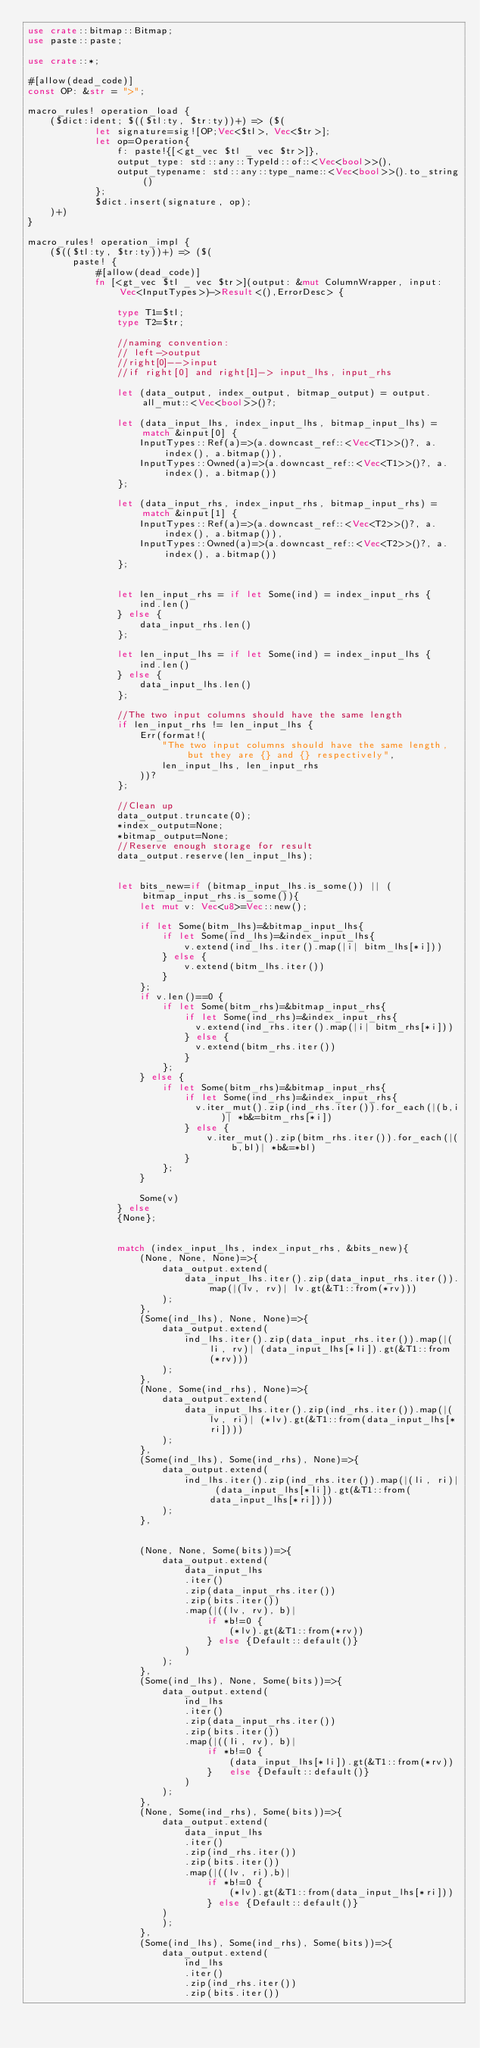<code> <loc_0><loc_0><loc_500><loc_500><_Rust_>use crate::bitmap::Bitmap;
use paste::paste;

use crate::*;

#[allow(dead_code)]
const OP: &str = ">";

macro_rules! operation_load {
    ($dict:ident; $(($tl:ty, $tr:ty))+) => ($(
            let signature=sig![OP;Vec<$tl>, Vec<$tr>];
            let op=Operation{
                f: paste!{[<gt_vec $tl _ vec $tr>]},
                output_type: std::any::TypeId::of::<Vec<bool>>(),
                output_typename: std::any::type_name::<Vec<bool>>().to_string()
            };
            $dict.insert(signature, op);
    )+)
}

macro_rules! operation_impl {
    ($(($tl:ty, $tr:ty))+) => ($(
        paste! {
            #[allow(dead_code)]
            fn [<gt_vec $tl _ vec $tr>](output: &mut ColumnWrapper, input: Vec<InputTypes>)->Result<(),ErrorDesc> {

                type T1=$tl;
                type T2=$tr;

                //naming convention:
                // left->output
                //right[0]-->input
                //if right[0] and right[1]-> input_lhs, input_rhs

                let (data_output, index_output, bitmap_output) = output.all_mut::<Vec<bool>>()?;

                let (data_input_lhs, index_input_lhs, bitmap_input_lhs) = match &input[0] {
                    InputTypes::Ref(a)=>(a.downcast_ref::<Vec<T1>>()?, a.index(), a.bitmap()),
                    InputTypes::Owned(a)=>(a.downcast_ref::<Vec<T1>>()?, a.index(), a.bitmap())
                };

                let (data_input_rhs, index_input_rhs, bitmap_input_rhs) = match &input[1] {
                    InputTypes::Ref(a)=>(a.downcast_ref::<Vec<T2>>()?, a.index(), a.bitmap()),
                    InputTypes::Owned(a)=>(a.downcast_ref::<Vec<T2>>()?, a.index(), a.bitmap())
                };


                let len_input_rhs = if let Some(ind) = index_input_rhs {
                    ind.len()
                } else {
                    data_input_rhs.len()
                };

                let len_input_lhs = if let Some(ind) = index_input_lhs {
                    ind.len()
                } else {
                    data_input_lhs.len()
                };

                //The two input columns should have the same length
                if len_input_rhs != len_input_lhs {
                    Err(format!(
                        "The two input columns should have the same length, but they are {} and {} respectively",
                        len_input_lhs, len_input_rhs
                    ))?
                };

                //Clean up
                data_output.truncate(0);
                *index_output=None;
                *bitmap_output=None;
                //Reserve enough storage for result
                data_output.reserve(len_input_lhs);


                let bits_new=if (bitmap_input_lhs.is_some()) || (bitmap_input_rhs.is_some()){
                    let mut v: Vec<u8>=Vec::new();

                    if let Some(bitm_lhs)=&bitmap_input_lhs{
                        if let Some(ind_lhs)=&index_input_lhs{
                            v.extend(ind_lhs.iter().map(|i| bitm_lhs[*i]))
                        } else {
                            v.extend(bitm_lhs.iter())
                        }
                    };
                    if v.len()==0 {
                        if let Some(bitm_rhs)=&bitmap_input_rhs{
                            if let Some(ind_rhs)=&index_input_rhs{
                              v.extend(ind_rhs.iter().map(|i| bitm_rhs[*i]))
                            } else {
                              v.extend(bitm_rhs.iter())
                            }
                        };
                    } else {
                        if let Some(bitm_rhs)=&bitmap_input_rhs{
                            if let Some(ind_rhs)=&index_input_rhs{
                              v.iter_mut().zip(ind_rhs.iter()).for_each(|(b,i)| *b&=bitm_rhs[*i])
                            } else {
                                v.iter_mut().zip(bitm_rhs.iter()).for_each(|(b,bl)| *b&=*bl)
                            }
                        };
                    }

                    Some(v)
                } else
                {None};


                match (index_input_lhs, index_input_rhs, &bits_new){
                    (None, None, None)=>{
                        data_output.extend(
                            data_input_lhs.iter().zip(data_input_rhs.iter()).map(|(lv, rv)| lv.gt(&T1::from(*rv)))
                        );
                    },
                    (Some(ind_lhs), None, None)=>{
                        data_output.extend(
                            ind_lhs.iter().zip(data_input_rhs.iter()).map(|(li, rv)| (data_input_lhs[*li]).gt(&T1::from(*rv)))
                        );
                    },
                    (None, Some(ind_rhs), None)=>{
                        data_output.extend(
                            data_input_lhs.iter().zip(ind_rhs.iter()).map(|(lv, ri)| (*lv).gt(&T1::from(data_input_lhs[*ri])))
                        );
                    },
                    (Some(ind_lhs), Some(ind_rhs), None)=>{
                        data_output.extend(
                            ind_lhs.iter().zip(ind_rhs.iter()).map(|(li, ri)| (data_input_lhs[*li]).gt(&T1::from(data_input_lhs[*ri])))
                        );
                    },


                    (None, None, Some(bits))=>{
                        data_output.extend(
                            data_input_lhs
                            .iter()
                            .zip(data_input_rhs.iter())
                            .zip(bits.iter())
                            .map(|((lv, rv), b)|
                                if *b!=0 {
                                    (*lv).gt(&T1::from(*rv))
                                } else {Default::default()}
                            )
                        );
                    },
                    (Some(ind_lhs), None, Some(bits))=>{
                        data_output.extend(
                            ind_lhs
                            .iter()
                            .zip(data_input_rhs.iter())
                            .zip(bits.iter())
                            .map(|((li, rv), b)|
                                if *b!=0 {
                                    (data_input_lhs[*li]).gt(&T1::from(*rv))
                                }   else {Default::default()}
                            )
                        );
                    },
                    (None, Some(ind_rhs), Some(bits))=>{
                        data_output.extend(
                            data_input_lhs
                            .iter()
                            .zip(ind_rhs.iter())
                            .zip(bits.iter())
                            .map(|((lv, ri),b)|
                                if *b!=0 {
                                    (*lv).gt(&T1::from(data_input_lhs[*ri]))
                                } else {Default::default()}
                        )
                        );
                    },
                    (Some(ind_lhs), Some(ind_rhs), Some(bits))=>{
                        data_output.extend(
                            ind_lhs
                            .iter()
                            .zip(ind_rhs.iter())
                            .zip(bits.iter())</code> 